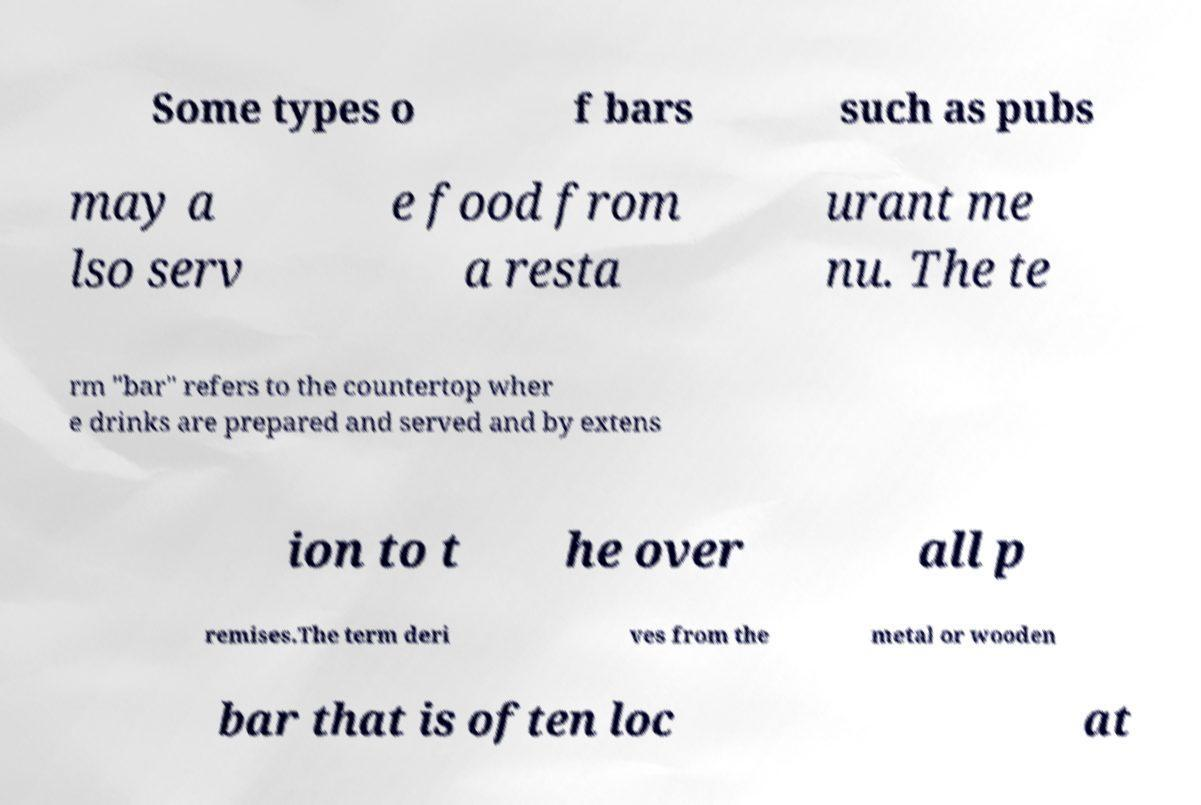Please identify and transcribe the text found in this image. Some types o f bars such as pubs may a lso serv e food from a resta urant me nu. The te rm "bar" refers to the countertop wher e drinks are prepared and served and by extens ion to t he over all p remises.The term deri ves from the metal or wooden bar that is often loc at 